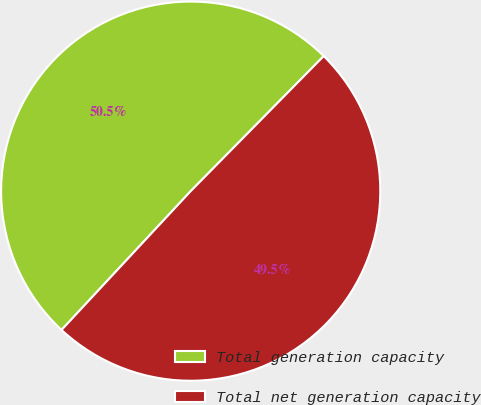Convert chart to OTSL. <chart><loc_0><loc_0><loc_500><loc_500><pie_chart><fcel>Total generation capacity<fcel>Total net generation capacity<nl><fcel>50.45%<fcel>49.55%<nl></chart> 